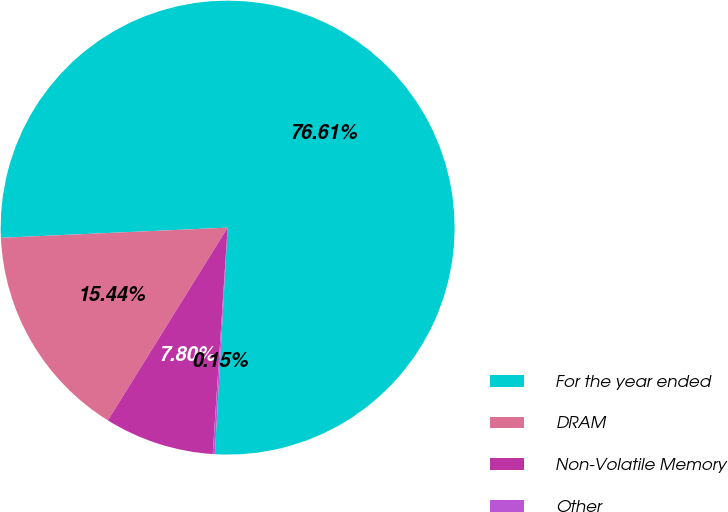Convert chart. <chart><loc_0><loc_0><loc_500><loc_500><pie_chart><fcel>For the year ended<fcel>DRAM<fcel>Non-Volatile Memory<fcel>Other<nl><fcel>76.61%<fcel>15.44%<fcel>7.8%<fcel>0.15%<nl></chart> 